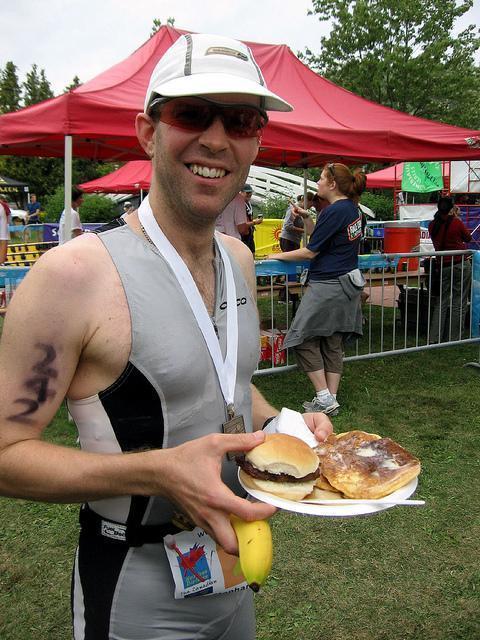Why does the man have numbers written on his arm?
Indicate the correct choice and explain in the format: 'Answer: answer
Rationale: rationale.'
Options: Tattoo, event participant, as joke, for surgery. Answer: event participant.
Rationale: The man is part of a event. 